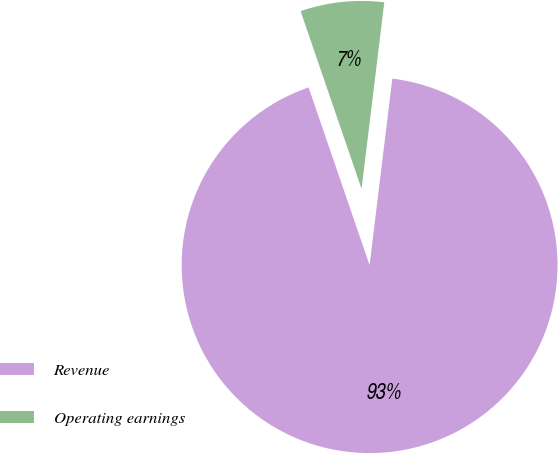<chart> <loc_0><loc_0><loc_500><loc_500><pie_chart><fcel>Revenue<fcel>Operating earnings<nl><fcel>92.81%<fcel>7.19%<nl></chart> 